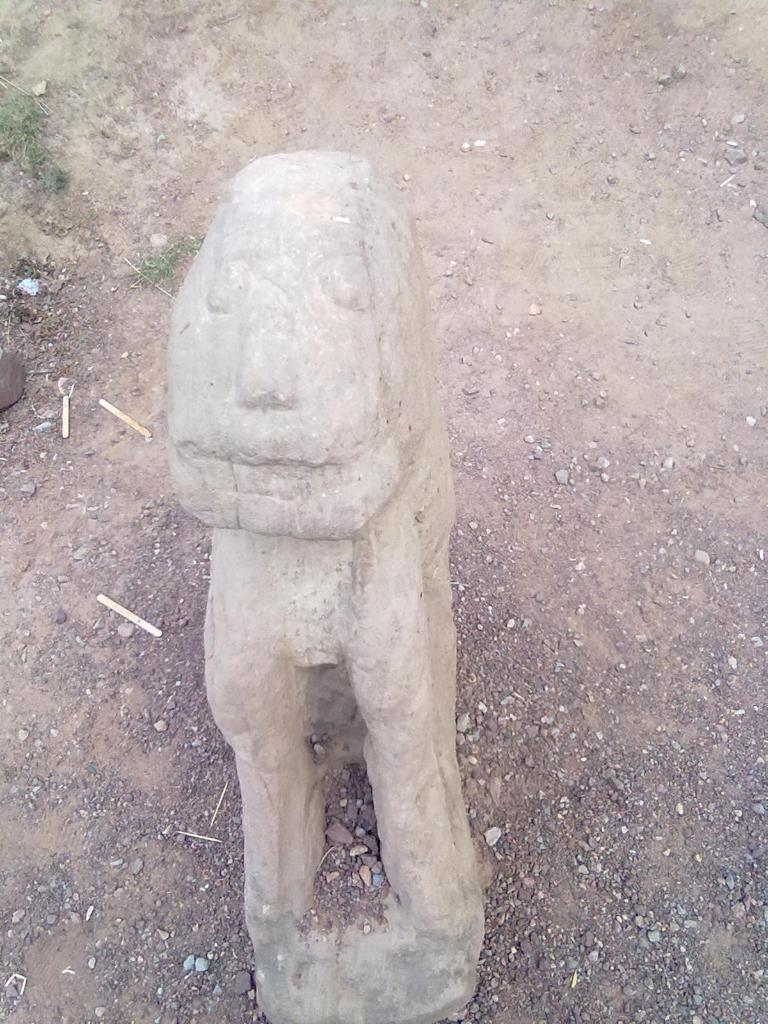What is located on the ground in the image? There is a sculpture on the ground in the image. What can be seen within the sculpture? There are small particles in the middle of the sculpture. What else is present on the ground in the image? There are sticks on the ground in the image. How long does it take for the sculpture to be fully digested in the image? The sculpture is not a living organism and therefore cannot be digested. The question is not relevant to the image. 